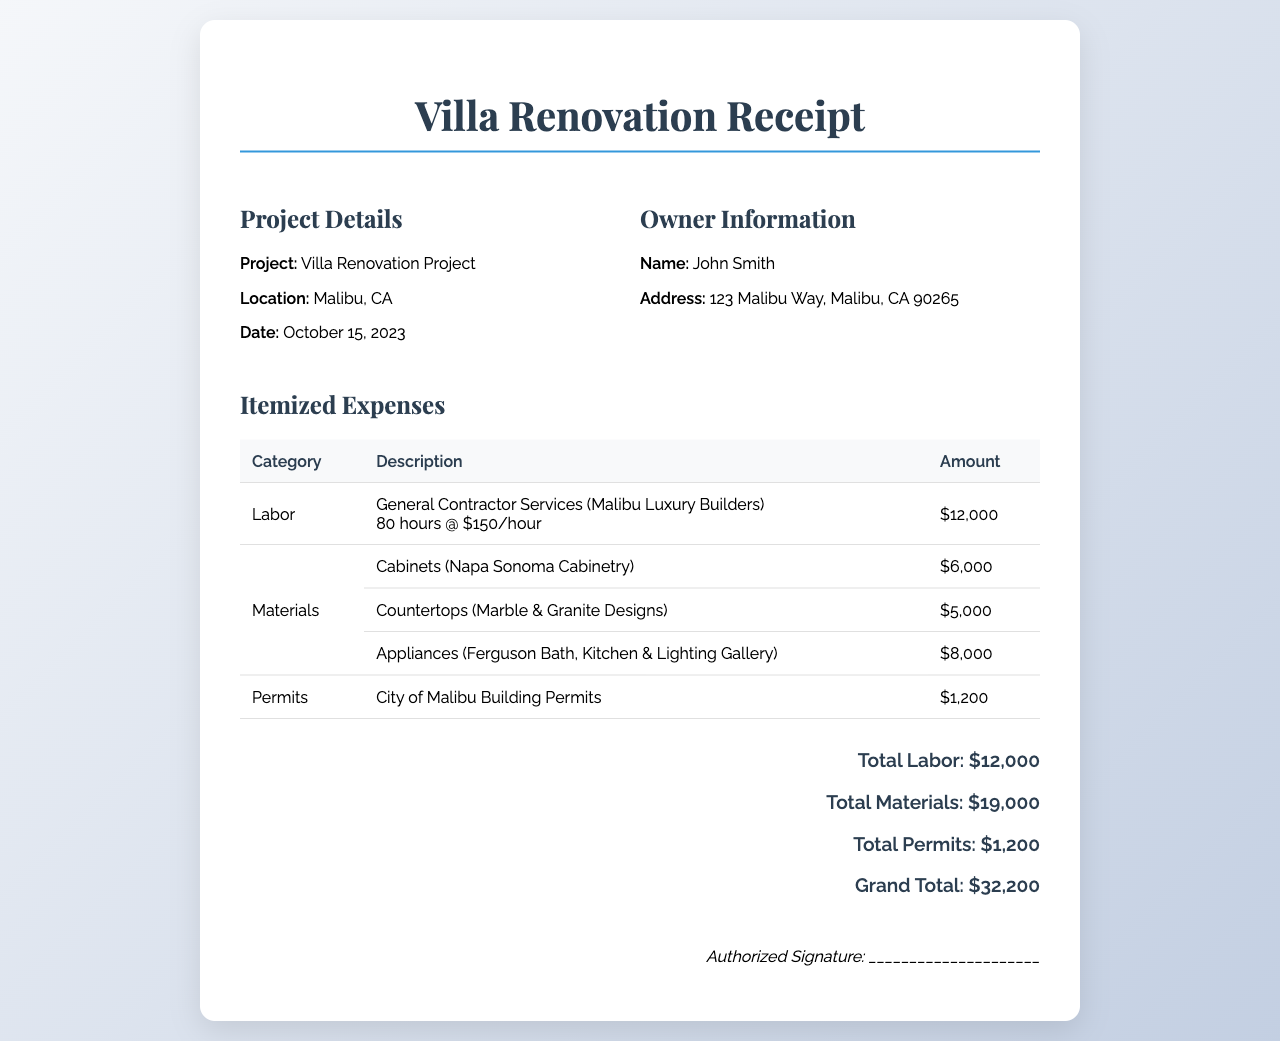what is the project location? The project is located in Malibu, California, as mentioned in the document.
Answer: Malibu, CA what is the total labor cost? The total labor cost is listed under the itemized expenses section.
Answer: $12,000 who is the general contractor? The general contractor for the services is mentioned in the labor description.
Answer: Malibu Luxury Builders how many hours were billed for labor? The document specifies the labor as 80 hours worked.
Answer: 80 hours what is the total cost of materials? The total amount for materials is the sum of individual material costs listed in the document.
Answer: $19,000 what is the cost of building permits? The permits section explicitly states the cost of permits for the project.
Answer: $1,200 what is the grand total for the renovation project? The grand total is provided at the end of the document summarizing all expenses.
Answer: $32,200 when was the project completed? The date of the project is given in the project details at the top of the receipt.
Answer: October 15, 2023 what is the owner's address? The owner's address is stated in the owner information section of the document.
Answer: 123 Malibu Way, Malibu, CA 90265 